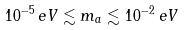Convert formula to latex. <formula><loc_0><loc_0><loc_500><loc_500>1 0 ^ { - 5 } \, e V \lesssim m _ { a } \lesssim 1 0 ^ { - 2 } \, e V</formula> 